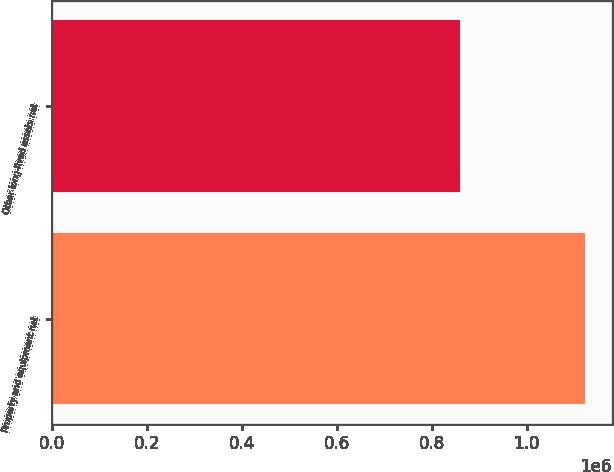Convert chart. <chart><loc_0><loc_0><loc_500><loc_500><bar_chart><fcel>Property and equipment net<fcel>Other long-lived assets net<nl><fcel>1.1236e+06<fcel>859023<nl></chart> 